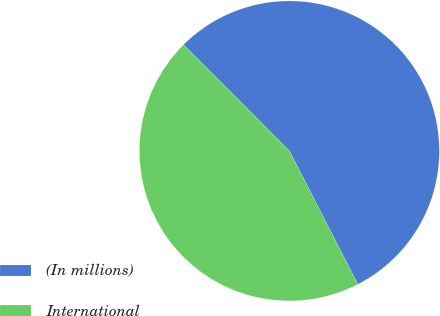Convert chart to OTSL. <chart><loc_0><loc_0><loc_500><loc_500><pie_chart><fcel>(In millions)<fcel>International<nl><fcel>54.93%<fcel>45.07%<nl></chart> 